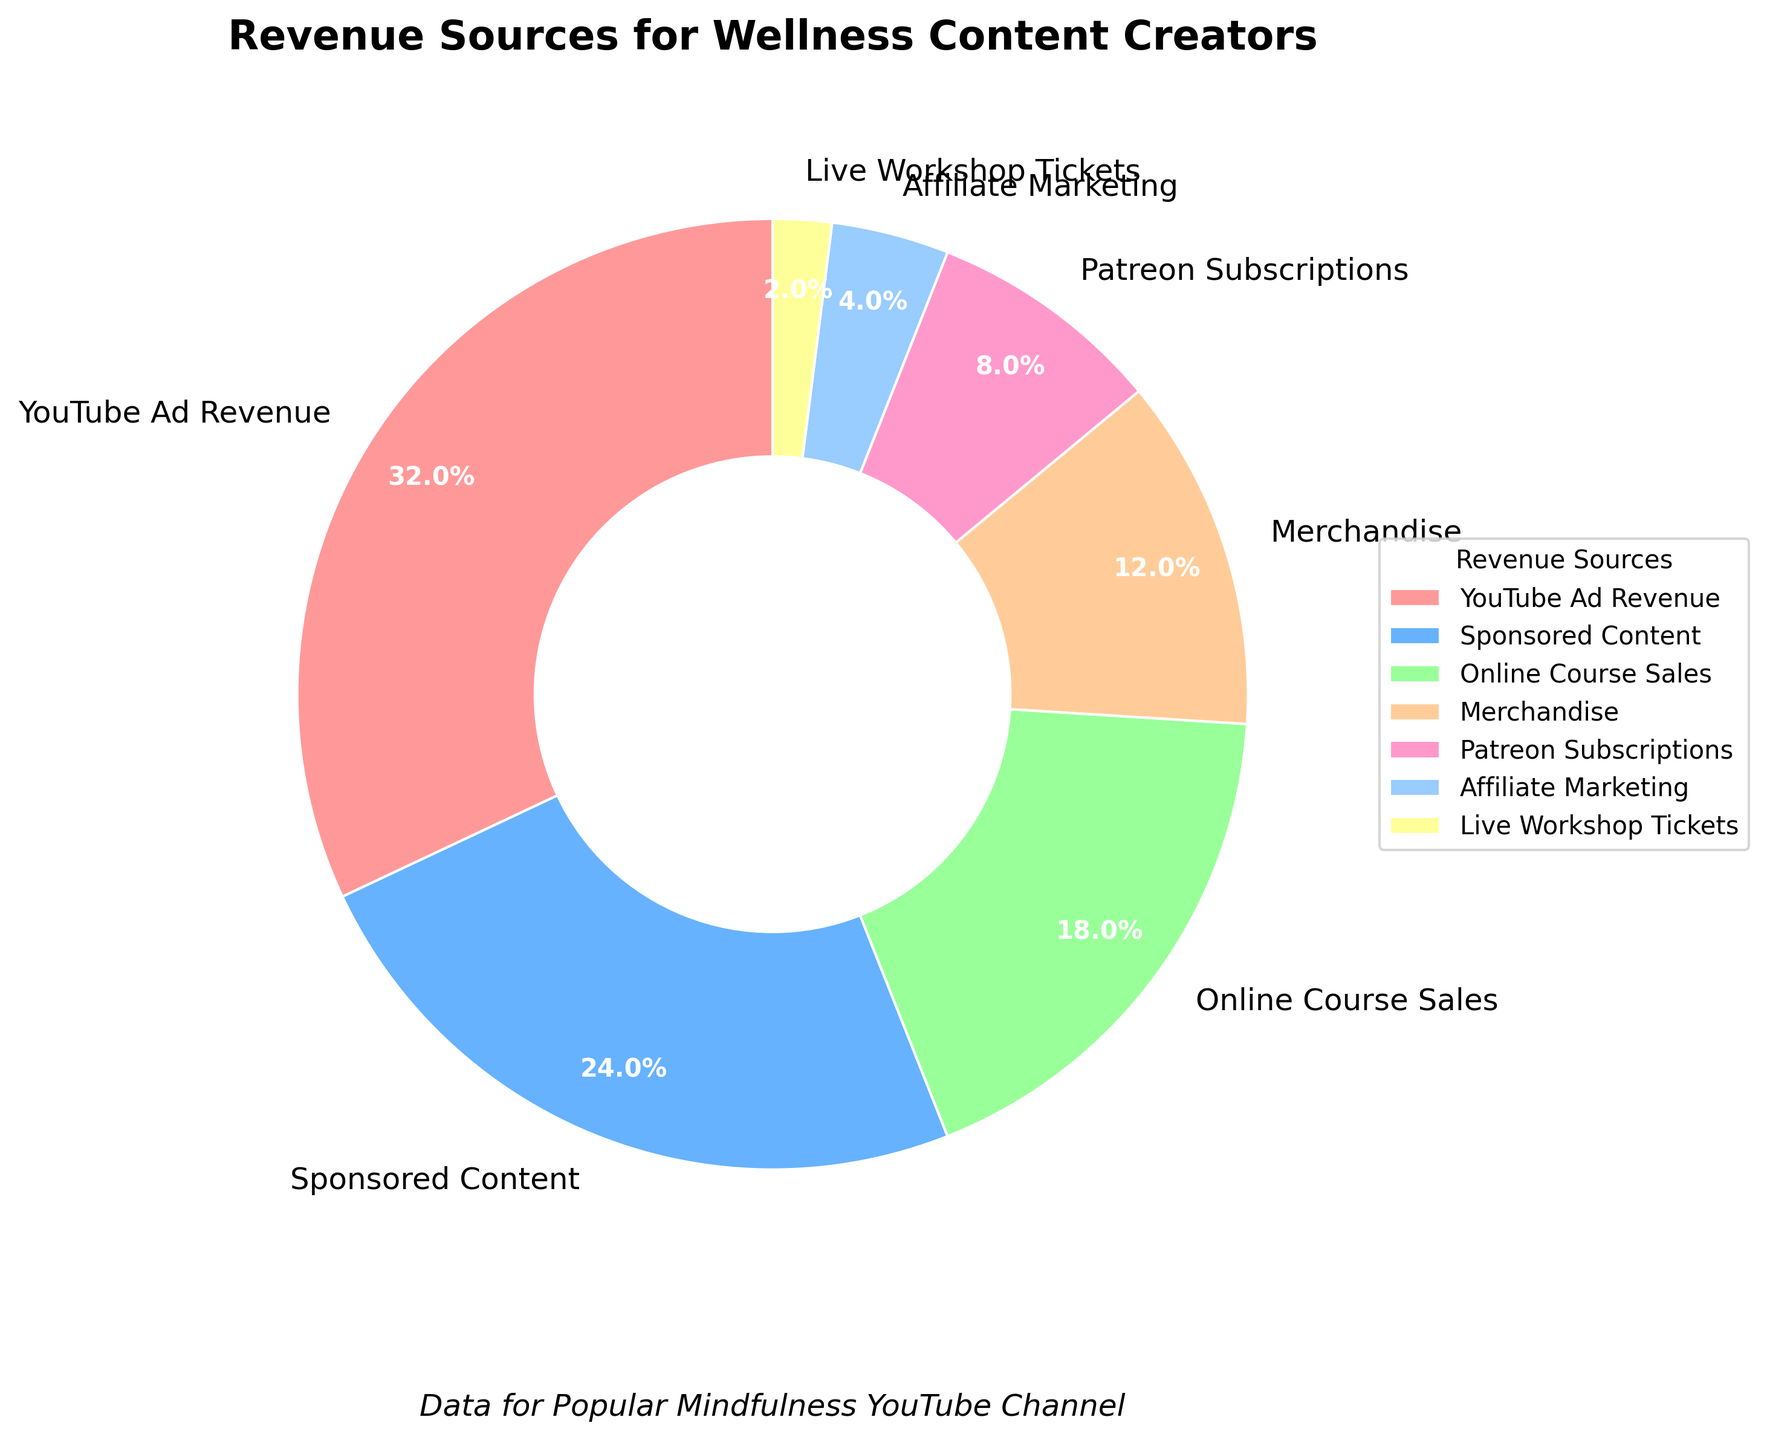What percentage of revenue comes from YouTube Ad Revenue and Sponsored Content combined? To find the combined percentage of YouTube Ad Revenue and Sponsored Content, simply add their percentages: 32% + 24%.
Answer: 56% Which revenue source contributes less to overall revenue: Affiliate Marketing or Live Workshop Tickets? Compare the percentages of Affiliate Marketing (4%) and Live Workshop Tickets (2%). Since 2% is less than 4%, Live Workshop Tickets contribute less.
Answer: Live Workshop Tickets What is the difference in percentage between Online Course Sales and Merchandise? Subtract the percentage of Merchandise (12%) from the percentage of Online Course Sales (18%): 18% - 12%.
Answer: 6% What color represents Patreon Subscriptions in the pie chart? Identify the color segment corresponding to Patreon Subscriptions in the chart legend, which is associated with an 8% slice.
Answer: Pink (varies depending on interpretation of #FF99CC) How much larger is the percentage of YouTube Ad Revenue compared to Affiliate Marketing? Subtract the percentage of Affiliate Marketing (4%) from YouTube Ad Revenue (32%): 32% - 4%.
Answer: 28% If YouTube Ad Revenue and Sponsored Content were combined into one category, would it be greater than 50% of the total revenue? Add the percentages of YouTube Ad Revenue (32%) and Sponsored Content (24%), then compare the sum to 50%: 32% + 24% = 56%, which is greater than 50%.
Answer: Yes What is the combined percentage of revenue from Patreon Subscriptions and Live Workshop Tickets? Add the percentages of Patreon Subscriptions (8%) and Live Workshop Tickets (2%): 8% + 2%.
Answer: 10% Which revenue source has the highest percentage and which has the lowest? Identify the segments with the highest and lowest percentages: YouTube Ad Revenue (32%) is the highest, and Live Workshop Tickets (2%) is the lowest.
Answer: Highest: YouTube Ad Revenue, Lowest: Live Workshop Tickets Which revenue source is represented by the green color in the pie chart? Locate the green segment in the pie chart and match it with the label, which in this case corresponds to Online Course Sales (18%).
Answer: Online Course Sales By what factor is the revenue from Merchandise larger than that from Live Workshop Tickets? Divide the percentage of Merchandise (12%) by the percentage of Live Workshop Tickets (2%): 12 / 2 = 6.
Answer: 6 